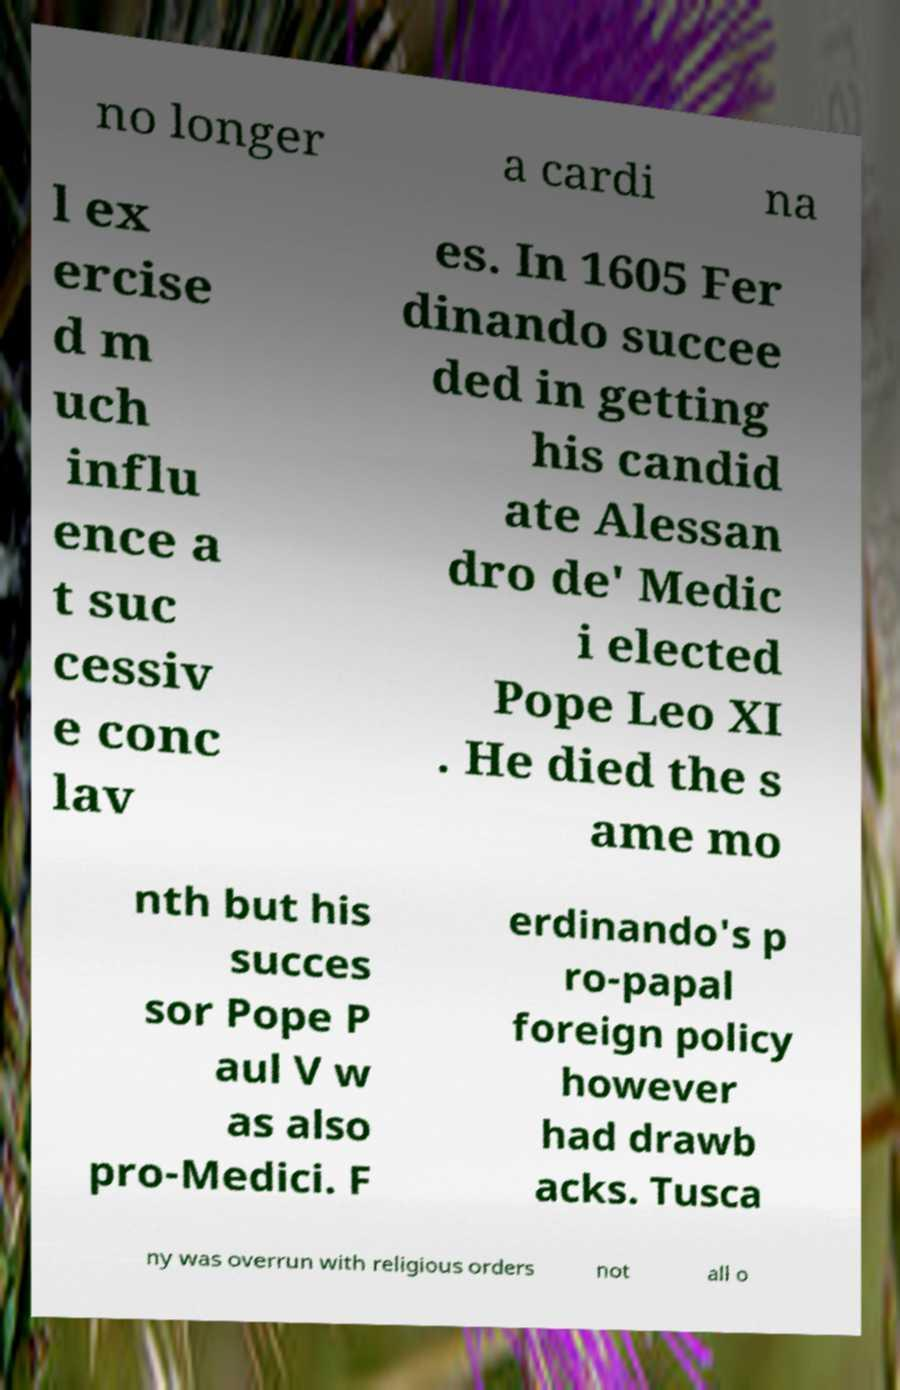For documentation purposes, I need the text within this image transcribed. Could you provide that? no longer a cardi na l ex ercise d m uch influ ence a t suc cessiv e conc lav es. In 1605 Fer dinando succee ded in getting his candid ate Alessan dro de' Medic i elected Pope Leo XI . He died the s ame mo nth but his succes sor Pope P aul V w as also pro-Medici. F erdinando's p ro-papal foreign policy however had drawb acks. Tusca ny was overrun with religious orders not all o 